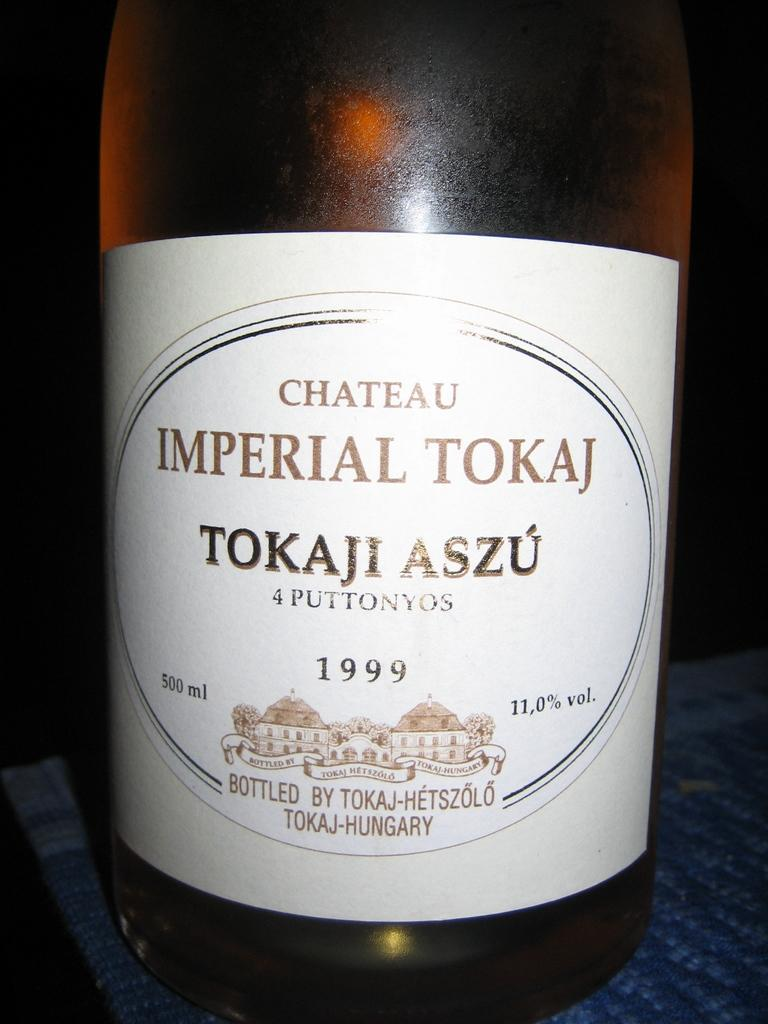<image>
Present a compact description of the photo's key features. A bottle of Chateau Imperial Tokaj is from 1999. 